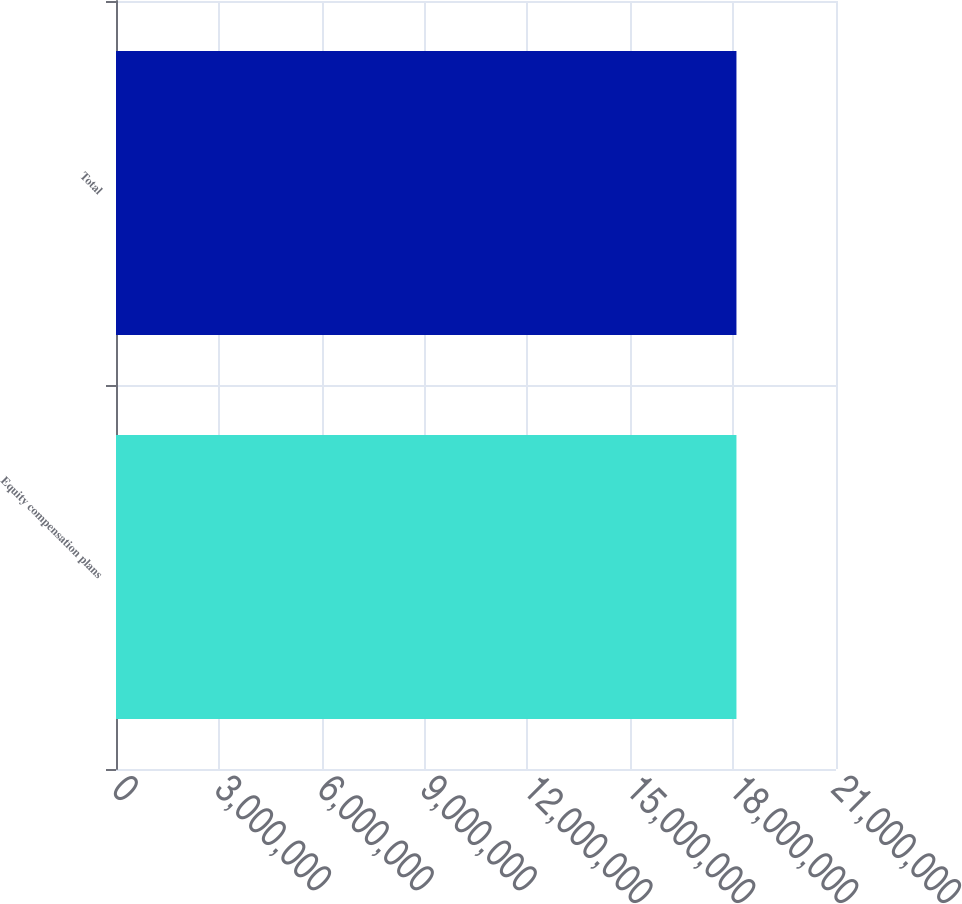<chart> <loc_0><loc_0><loc_500><loc_500><bar_chart><fcel>Equity compensation plans<fcel>Total<nl><fcel>1.80964e+07<fcel>1.80964e+07<nl></chart> 